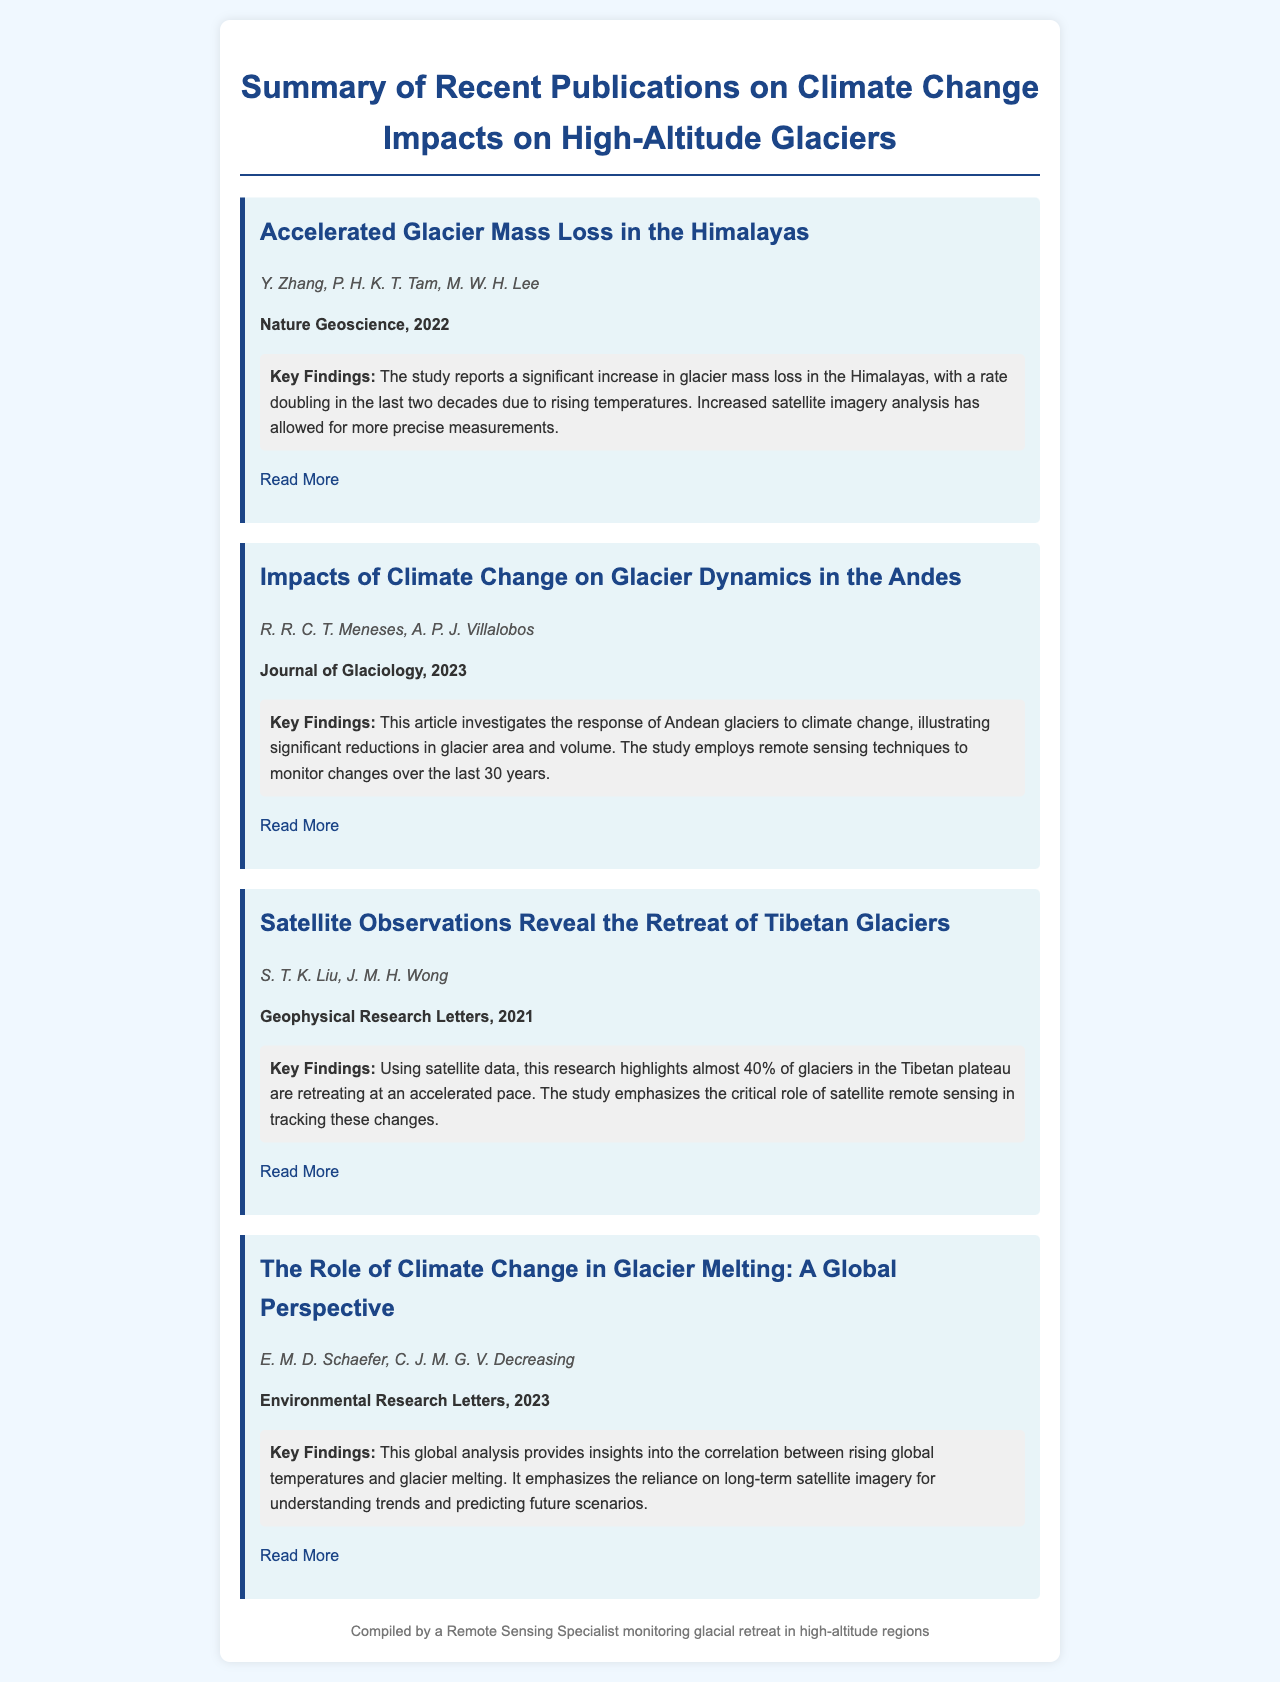What is the title of the first publication? The title of the first publication is mentioned in the document under the publication heading.
Answer: Accelerated Glacier Mass Loss in the Himalayas Who are the authors of the second publication? The authors of the second publication are listed directly under the publication heading.
Answer: R. R. C. T. Meneses, A. P. J. Villalobos In which journal was the article on Tibetan glaciers published? The journal for the Tibetan glaciers article is specified under the publication details.
Answer: Geophysical Research Letters What is the key finding of the study related to the Himalayas? The key finding related to the Himalayas summarizes the main result of that publication.
Answer: Significant increase in glacier mass loss How many years does the Andean glacier study cover? The time span of the Andean glacier study is mentioned in the key findings section of that publication.
Answer: 30 years What percentage of Tibet glaciers are retreating according to the third publication? The percentage is highlighted in the key findings of that publication.
Answer: Almost 40% Which publication emphasizes the role of long-term satellite imagery? This detail can be found in the key findings under a specific publication heading.
Answer: The Role of Climate Change in Glacier Melting: A Global Perspective How many authors contributed to the last publication? The number of authors is listed directly under the publication information.
Answer: 2 authors 